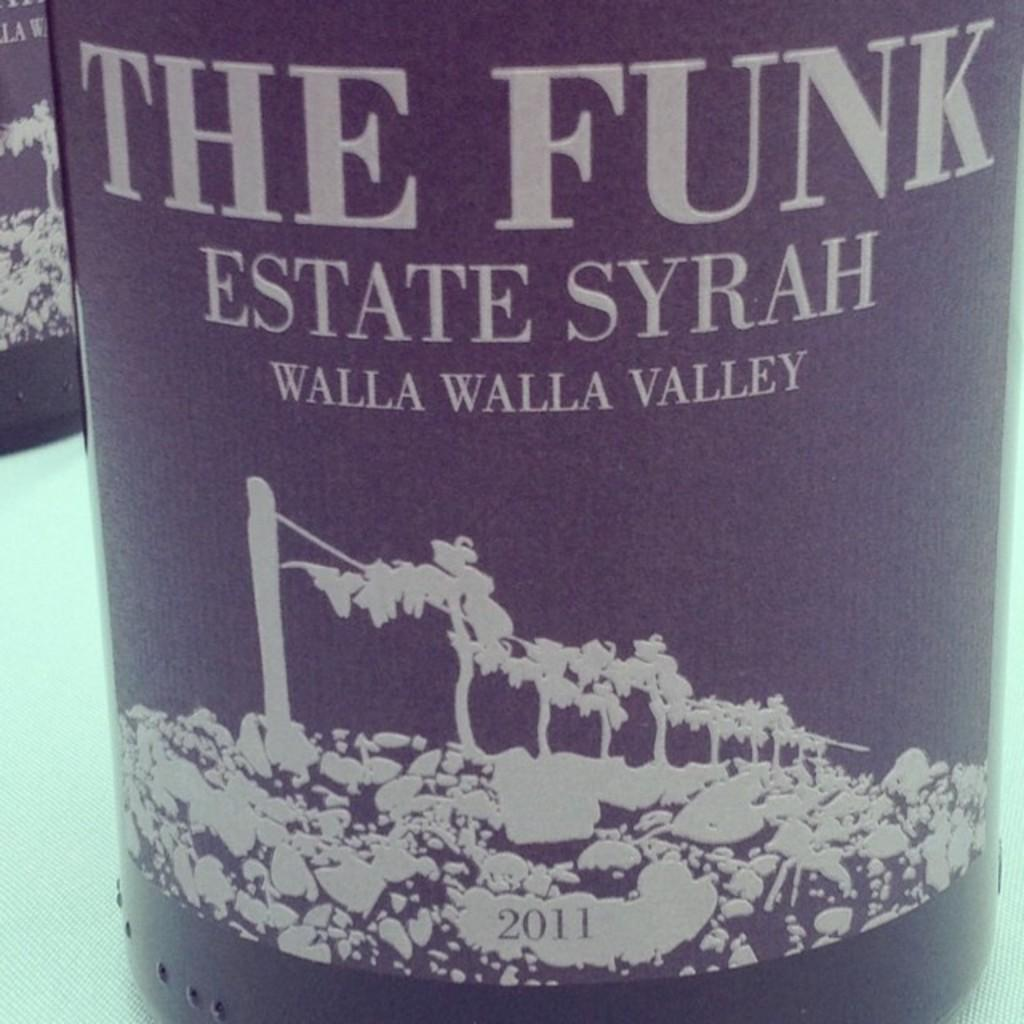<image>
Provide a brief description of the given image. A bottle of wine has a label that has the words THE FUNK ESTATE SYRAH WALLA WALLA VALLEY 